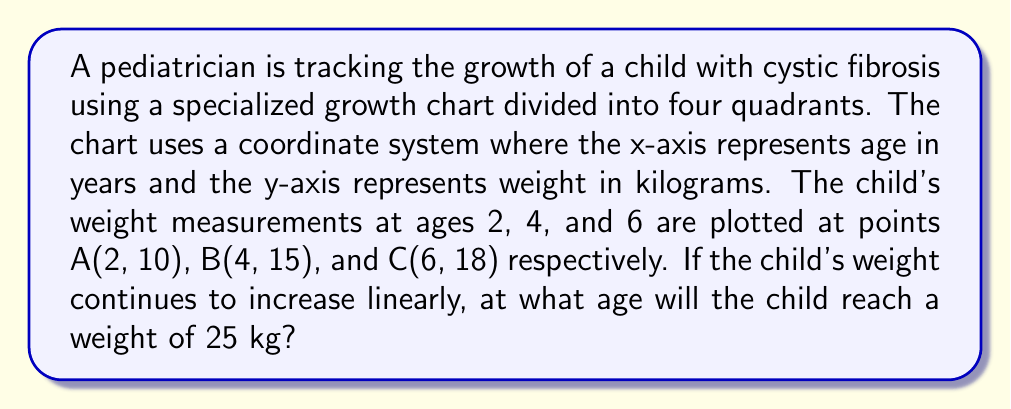Provide a solution to this math problem. To solve this problem, we need to follow these steps:

1. Determine the linear equation of the child's growth:
   We can use two points to find the slope and y-intercept of the line.
   Let's use points A(2, 10) and C(6, 18).

   Slope $m = \frac{y_2 - y_1}{x_2 - x_1} = \frac{18 - 10}{6 - 2} = \frac{8}{4} = 2$

   Using point-slope form: $y - y_1 = m(x - x_1)$
   $y - 10 = 2(x - 2)$
   $y - 10 = 2x - 4$
   $y = 2x - 4 + 10$
   $y = 2x + 6$

2. Now that we have the equation $y = 2x + 6$, we can solve for x when y = 25:

   $25 = 2x + 6$
   $19 = 2x$
   $x = \frac{19}{2} = 9.5$

Therefore, if the child's weight continues to increase linearly, they will reach 25 kg at age 9.5 years.
Answer: 9.5 years 